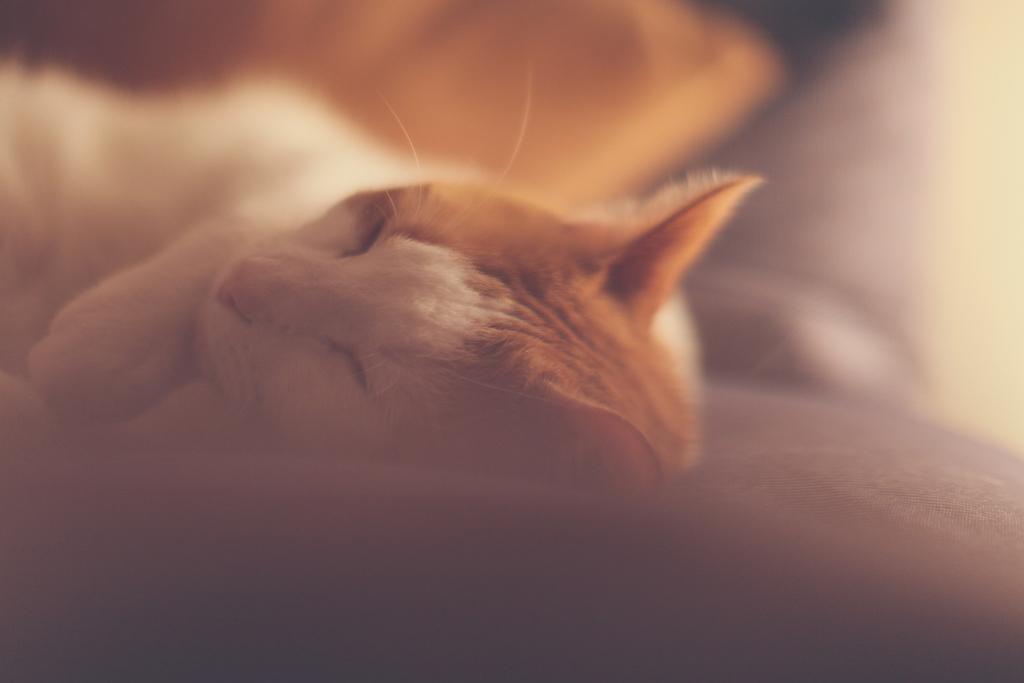In one or two sentences, can you explain what this image depicts? In this image, we can see the cat sleeping. 